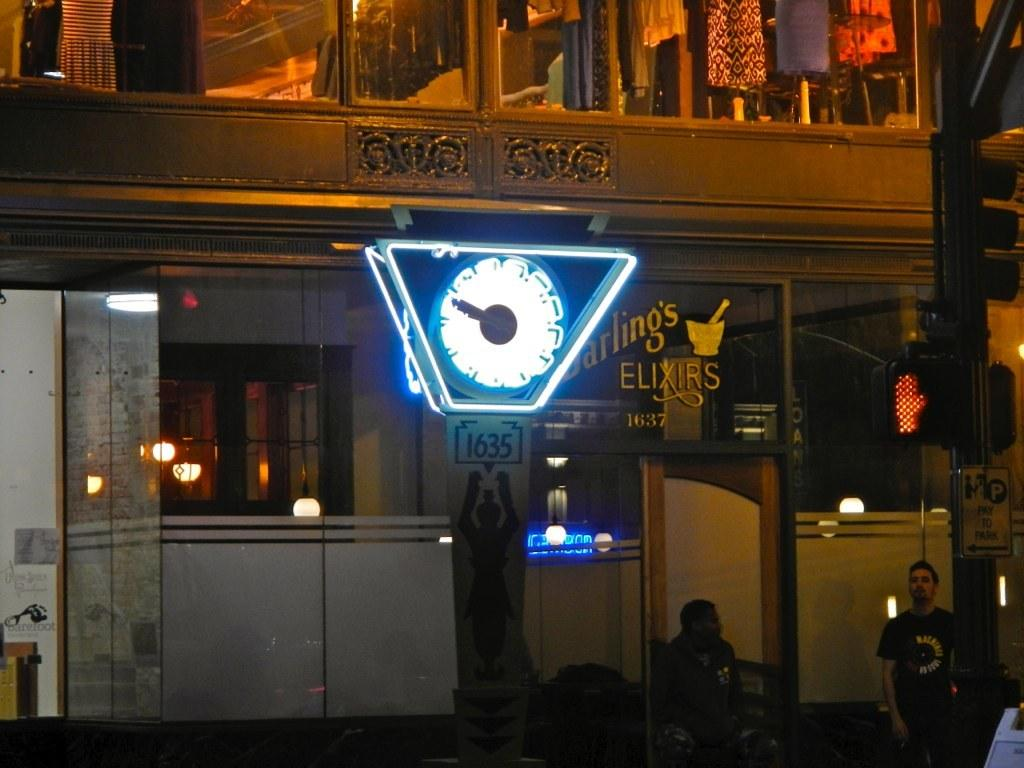What is the man doing in the image? The man is standing on the right side of the image. Can you describe the position of the other person in the image? There is a person sitting in the image. What type of items can be seen related to clothing in the image? Clothes are visible in the image. What object is used for measuring time in the image? There is a clock in the image. What type of illumination is present in the image? Lights are present in the image. What type of wound can be seen on the person's arm in the image? There is no wound visible on any person's arm in the image. 